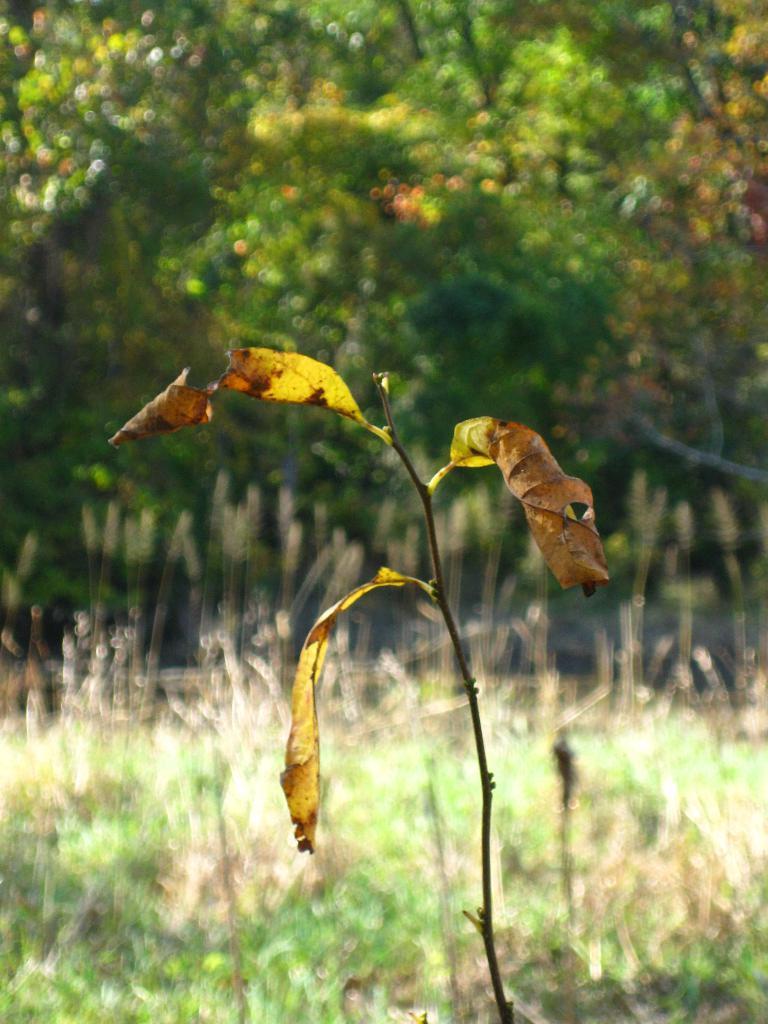Could you give a brief overview of what you see in this image? In this picture we can observe a plant which has dried leaves. There is some grass on the ground. In the background there are trees. 